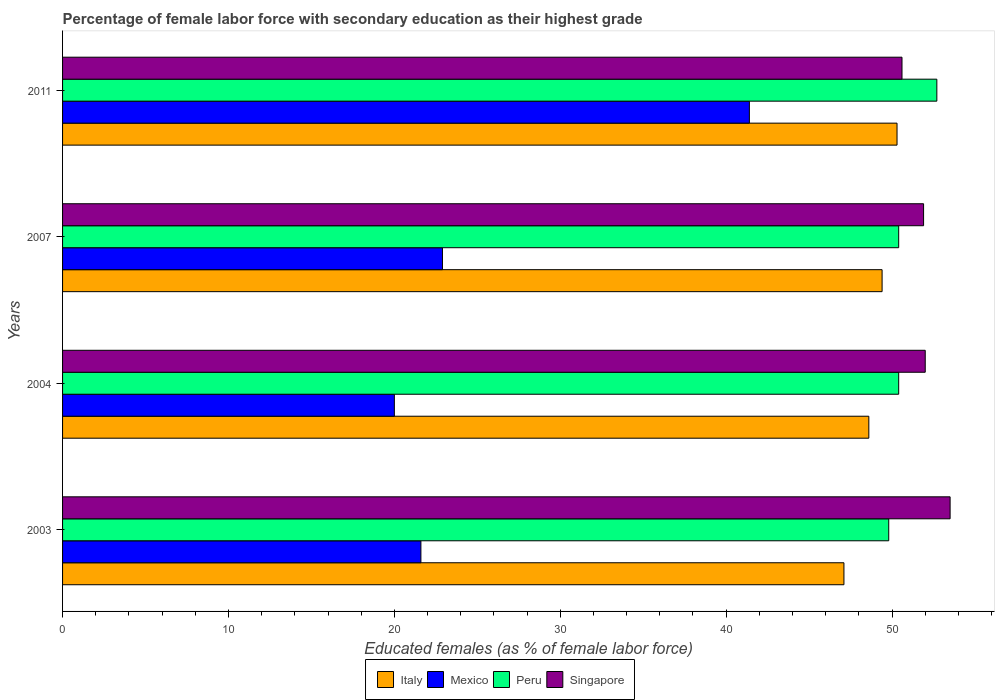Are the number of bars per tick equal to the number of legend labels?
Ensure brevity in your answer.  Yes. How many bars are there on the 4th tick from the bottom?
Ensure brevity in your answer.  4. In how many cases, is the number of bars for a given year not equal to the number of legend labels?
Offer a terse response. 0. What is the percentage of female labor force with secondary education in Singapore in 2003?
Provide a succinct answer. 53.5. Across all years, what is the maximum percentage of female labor force with secondary education in Mexico?
Ensure brevity in your answer.  41.4. Across all years, what is the minimum percentage of female labor force with secondary education in Peru?
Provide a succinct answer. 49.8. In which year was the percentage of female labor force with secondary education in Italy minimum?
Provide a succinct answer. 2003. What is the total percentage of female labor force with secondary education in Mexico in the graph?
Make the answer very short. 105.9. What is the difference between the percentage of female labor force with secondary education in Singapore in 2004 and that in 2007?
Make the answer very short. 0.1. What is the difference between the percentage of female labor force with secondary education in Peru in 2004 and the percentage of female labor force with secondary education in Mexico in 2007?
Offer a very short reply. 27.5. What is the average percentage of female labor force with secondary education in Italy per year?
Offer a very short reply. 48.85. In the year 2003, what is the difference between the percentage of female labor force with secondary education in Mexico and percentage of female labor force with secondary education in Singapore?
Your response must be concise. -31.9. In how many years, is the percentage of female labor force with secondary education in Singapore greater than 46 %?
Your answer should be very brief. 4. What is the ratio of the percentage of female labor force with secondary education in Singapore in 2003 to that in 2007?
Offer a terse response. 1.03. Is the percentage of female labor force with secondary education in Italy in 2003 less than that in 2004?
Offer a very short reply. Yes. What is the difference between the highest and the lowest percentage of female labor force with secondary education in Singapore?
Ensure brevity in your answer.  2.9. Is the sum of the percentage of female labor force with secondary education in Mexico in 2003 and 2011 greater than the maximum percentage of female labor force with secondary education in Singapore across all years?
Offer a very short reply. Yes. Is it the case that in every year, the sum of the percentage of female labor force with secondary education in Italy and percentage of female labor force with secondary education in Peru is greater than the sum of percentage of female labor force with secondary education in Mexico and percentage of female labor force with secondary education in Singapore?
Provide a short and direct response. No. What does the 1st bar from the top in 2004 represents?
Provide a short and direct response. Singapore. What does the 1st bar from the bottom in 2004 represents?
Your answer should be compact. Italy. Is it the case that in every year, the sum of the percentage of female labor force with secondary education in Singapore and percentage of female labor force with secondary education in Mexico is greater than the percentage of female labor force with secondary education in Peru?
Offer a very short reply. Yes. How many bars are there?
Keep it short and to the point. 16. What is the difference between two consecutive major ticks on the X-axis?
Give a very brief answer. 10. Are the values on the major ticks of X-axis written in scientific E-notation?
Provide a short and direct response. No. Does the graph contain any zero values?
Your response must be concise. No. Where does the legend appear in the graph?
Offer a terse response. Bottom center. How many legend labels are there?
Your answer should be compact. 4. What is the title of the graph?
Your answer should be compact. Percentage of female labor force with secondary education as their highest grade. Does "Bangladesh" appear as one of the legend labels in the graph?
Offer a very short reply. No. What is the label or title of the X-axis?
Make the answer very short. Educated females (as % of female labor force). What is the label or title of the Y-axis?
Keep it short and to the point. Years. What is the Educated females (as % of female labor force) in Italy in 2003?
Offer a terse response. 47.1. What is the Educated females (as % of female labor force) of Mexico in 2003?
Make the answer very short. 21.6. What is the Educated females (as % of female labor force) of Peru in 2003?
Make the answer very short. 49.8. What is the Educated females (as % of female labor force) of Singapore in 2003?
Your answer should be compact. 53.5. What is the Educated females (as % of female labor force) of Italy in 2004?
Provide a succinct answer. 48.6. What is the Educated females (as % of female labor force) of Mexico in 2004?
Offer a very short reply. 20. What is the Educated females (as % of female labor force) in Peru in 2004?
Your response must be concise. 50.4. What is the Educated females (as % of female labor force) of Singapore in 2004?
Offer a very short reply. 52. What is the Educated females (as % of female labor force) of Italy in 2007?
Ensure brevity in your answer.  49.4. What is the Educated females (as % of female labor force) in Mexico in 2007?
Provide a short and direct response. 22.9. What is the Educated females (as % of female labor force) in Peru in 2007?
Make the answer very short. 50.4. What is the Educated females (as % of female labor force) in Singapore in 2007?
Give a very brief answer. 51.9. What is the Educated females (as % of female labor force) of Italy in 2011?
Ensure brevity in your answer.  50.3. What is the Educated females (as % of female labor force) of Mexico in 2011?
Keep it short and to the point. 41.4. What is the Educated females (as % of female labor force) of Peru in 2011?
Your response must be concise. 52.7. What is the Educated females (as % of female labor force) of Singapore in 2011?
Ensure brevity in your answer.  50.6. Across all years, what is the maximum Educated females (as % of female labor force) in Italy?
Offer a very short reply. 50.3. Across all years, what is the maximum Educated females (as % of female labor force) of Mexico?
Ensure brevity in your answer.  41.4. Across all years, what is the maximum Educated females (as % of female labor force) of Peru?
Give a very brief answer. 52.7. Across all years, what is the maximum Educated females (as % of female labor force) in Singapore?
Provide a succinct answer. 53.5. Across all years, what is the minimum Educated females (as % of female labor force) of Italy?
Make the answer very short. 47.1. Across all years, what is the minimum Educated females (as % of female labor force) of Peru?
Keep it short and to the point. 49.8. Across all years, what is the minimum Educated females (as % of female labor force) in Singapore?
Give a very brief answer. 50.6. What is the total Educated females (as % of female labor force) of Italy in the graph?
Provide a succinct answer. 195.4. What is the total Educated females (as % of female labor force) of Mexico in the graph?
Provide a short and direct response. 105.9. What is the total Educated females (as % of female labor force) of Peru in the graph?
Make the answer very short. 203.3. What is the total Educated females (as % of female labor force) of Singapore in the graph?
Make the answer very short. 208. What is the difference between the Educated females (as % of female labor force) in Singapore in 2003 and that in 2004?
Keep it short and to the point. 1.5. What is the difference between the Educated females (as % of female labor force) of Italy in 2003 and that in 2007?
Your answer should be compact. -2.3. What is the difference between the Educated females (as % of female labor force) of Singapore in 2003 and that in 2007?
Offer a very short reply. 1.6. What is the difference between the Educated females (as % of female labor force) of Mexico in 2003 and that in 2011?
Provide a succinct answer. -19.8. What is the difference between the Educated females (as % of female labor force) of Peru in 2003 and that in 2011?
Keep it short and to the point. -2.9. What is the difference between the Educated females (as % of female labor force) in Singapore in 2003 and that in 2011?
Your answer should be very brief. 2.9. What is the difference between the Educated females (as % of female labor force) in Peru in 2004 and that in 2007?
Your answer should be compact. 0. What is the difference between the Educated females (as % of female labor force) in Mexico in 2004 and that in 2011?
Keep it short and to the point. -21.4. What is the difference between the Educated females (as % of female labor force) of Mexico in 2007 and that in 2011?
Your response must be concise. -18.5. What is the difference between the Educated females (as % of female labor force) in Peru in 2007 and that in 2011?
Provide a short and direct response. -2.3. What is the difference between the Educated females (as % of female labor force) in Italy in 2003 and the Educated females (as % of female labor force) in Mexico in 2004?
Offer a very short reply. 27.1. What is the difference between the Educated females (as % of female labor force) of Italy in 2003 and the Educated females (as % of female labor force) of Peru in 2004?
Your response must be concise. -3.3. What is the difference between the Educated females (as % of female labor force) of Mexico in 2003 and the Educated females (as % of female labor force) of Peru in 2004?
Provide a succinct answer. -28.8. What is the difference between the Educated females (as % of female labor force) of Mexico in 2003 and the Educated females (as % of female labor force) of Singapore in 2004?
Provide a short and direct response. -30.4. What is the difference between the Educated females (as % of female labor force) in Peru in 2003 and the Educated females (as % of female labor force) in Singapore in 2004?
Make the answer very short. -2.2. What is the difference between the Educated females (as % of female labor force) of Italy in 2003 and the Educated females (as % of female labor force) of Mexico in 2007?
Make the answer very short. 24.2. What is the difference between the Educated females (as % of female labor force) of Italy in 2003 and the Educated females (as % of female labor force) of Peru in 2007?
Provide a short and direct response. -3.3. What is the difference between the Educated females (as % of female labor force) of Mexico in 2003 and the Educated females (as % of female labor force) of Peru in 2007?
Your answer should be very brief. -28.8. What is the difference between the Educated females (as % of female labor force) in Mexico in 2003 and the Educated females (as % of female labor force) in Singapore in 2007?
Your answer should be very brief. -30.3. What is the difference between the Educated females (as % of female labor force) in Peru in 2003 and the Educated females (as % of female labor force) in Singapore in 2007?
Your answer should be compact. -2.1. What is the difference between the Educated females (as % of female labor force) in Italy in 2003 and the Educated females (as % of female labor force) in Mexico in 2011?
Keep it short and to the point. 5.7. What is the difference between the Educated females (as % of female labor force) in Mexico in 2003 and the Educated females (as % of female labor force) in Peru in 2011?
Your answer should be very brief. -31.1. What is the difference between the Educated females (as % of female labor force) of Mexico in 2003 and the Educated females (as % of female labor force) of Singapore in 2011?
Provide a short and direct response. -29. What is the difference between the Educated females (as % of female labor force) in Peru in 2003 and the Educated females (as % of female labor force) in Singapore in 2011?
Your response must be concise. -0.8. What is the difference between the Educated females (as % of female labor force) in Italy in 2004 and the Educated females (as % of female labor force) in Mexico in 2007?
Your response must be concise. 25.7. What is the difference between the Educated females (as % of female labor force) of Italy in 2004 and the Educated females (as % of female labor force) of Peru in 2007?
Provide a succinct answer. -1.8. What is the difference between the Educated females (as % of female labor force) of Mexico in 2004 and the Educated females (as % of female labor force) of Peru in 2007?
Offer a terse response. -30.4. What is the difference between the Educated females (as % of female labor force) in Mexico in 2004 and the Educated females (as % of female labor force) in Singapore in 2007?
Provide a succinct answer. -31.9. What is the difference between the Educated females (as % of female labor force) in Peru in 2004 and the Educated females (as % of female labor force) in Singapore in 2007?
Offer a terse response. -1.5. What is the difference between the Educated females (as % of female labor force) of Italy in 2004 and the Educated females (as % of female labor force) of Mexico in 2011?
Make the answer very short. 7.2. What is the difference between the Educated females (as % of female labor force) of Italy in 2004 and the Educated females (as % of female labor force) of Peru in 2011?
Provide a short and direct response. -4.1. What is the difference between the Educated females (as % of female labor force) of Mexico in 2004 and the Educated females (as % of female labor force) of Peru in 2011?
Keep it short and to the point. -32.7. What is the difference between the Educated females (as % of female labor force) of Mexico in 2004 and the Educated females (as % of female labor force) of Singapore in 2011?
Make the answer very short. -30.6. What is the difference between the Educated females (as % of female labor force) in Italy in 2007 and the Educated females (as % of female labor force) in Singapore in 2011?
Ensure brevity in your answer.  -1.2. What is the difference between the Educated females (as % of female labor force) in Mexico in 2007 and the Educated females (as % of female labor force) in Peru in 2011?
Ensure brevity in your answer.  -29.8. What is the difference between the Educated females (as % of female labor force) in Mexico in 2007 and the Educated females (as % of female labor force) in Singapore in 2011?
Keep it short and to the point. -27.7. What is the difference between the Educated females (as % of female labor force) in Peru in 2007 and the Educated females (as % of female labor force) in Singapore in 2011?
Offer a terse response. -0.2. What is the average Educated females (as % of female labor force) of Italy per year?
Your response must be concise. 48.85. What is the average Educated females (as % of female labor force) of Mexico per year?
Offer a very short reply. 26.48. What is the average Educated females (as % of female labor force) in Peru per year?
Offer a terse response. 50.83. In the year 2003, what is the difference between the Educated females (as % of female labor force) in Italy and Educated females (as % of female labor force) in Peru?
Keep it short and to the point. -2.7. In the year 2003, what is the difference between the Educated females (as % of female labor force) of Mexico and Educated females (as % of female labor force) of Peru?
Your response must be concise. -28.2. In the year 2003, what is the difference between the Educated females (as % of female labor force) in Mexico and Educated females (as % of female labor force) in Singapore?
Ensure brevity in your answer.  -31.9. In the year 2004, what is the difference between the Educated females (as % of female labor force) in Italy and Educated females (as % of female labor force) in Mexico?
Offer a very short reply. 28.6. In the year 2004, what is the difference between the Educated females (as % of female labor force) in Italy and Educated females (as % of female labor force) in Peru?
Provide a succinct answer. -1.8. In the year 2004, what is the difference between the Educated females (as % of female labor force) in Mexico and Educated females (as % of female labor force) in Peru?
Give a very brief answer. -30.4. In the year 2004, what is the difference between the Educated females (as % of female labor force) in Mexico and Educated females (as % of female labor force) in Singapore?
Your response must be concise. -32. In the year 2007, what is the difference between the Educated females (as % of female labor force) of Italy and Educated females (as % of female labor force) of Mexico?
Offer a terse response. 26.5. In the year 2007, what is the difference between the Educated females (as % of female labor force) in Italy and Educated females (as % of female labor force) in Peru?
Make the answer very short. -1. In the year 2007, what is the difference between the Educated females (as % of female labor force) in Italy and Educated females (as % of female labor force) in Singapore?
Your answer should be compact. -2.5. In the year 2007, what is the difference between the Educated females (as % of female labor force) in Mexico and Educated females (as % of female labor force) in Peru?
Keep it short and to the point. -27.5. In the year 2007, what is the difference between the Educated females (as % of female labor force) in Peru and Educated females (as % of female labor force) in Singapore?
Ensure brevity in your answer.  -1.5. In the year 2011, what is the difference between the Educated females (as % of female labor force) in Italy and Educated females (as % of female labor force) in Mexico?
Offer a terse response. 8.9. In the year 2011, what is the difference between the Educated females (as % of female labor force) in Italy and Educated females (as % of female labor force) in Peru?
Provide a succinct answer. -2.4. In the year 2011, what is the difference between the Educated females (as % of female labor force) in Italy and Educated females (as % of female labor force) in Singapore?
Provide a succinct answer. -0.3. In the year 2011, what is the difference between the Educated females (as % of female labor force) in Mexico and Educated females (as % of female labor force) in Singapore?
Ensure brevity in your answer.  -9.2. What is the ratio of the Educated females (as % of female labor force) of Italy in 2003 to that in 2004?
Make the answer very short. 0.97. What is the ratio of the Educated females (as % of female labor force) in Singapore in 2003 to that in 2004?
Offer a very short reply. 1.03. What is the ratio of the Educated females (as % of female labor force) of Italy in 2003 to that in 2007?
Your answer should be very brief. 0.95. What is the ratio of the Educated females (as % of female labor force) of Mexico in 2003 to that in 2007?
Give a very brief answer. 0.94. What is the ratio of the Educated females (as % of female labor force) in Peru in 2003 to that in 2007?
Provide a succinct answer. 0.99. What is the ratio of the Educated females (as % of female labor force) in Singapore in 2003 to that in 2007?
Ensure brevity in your answer.  1.03. What is the ratio of the Educated females (as % of female labor force) in Italy in 2003 to that in 2011?
Offer a very short reply. 0.94. What is the ratio of the Educated females (as % of female labor force) of Mexico in 2003 to that in 2011?
Offer a terse response. 0.52. What is the ratio of the Educated females (as % of female labor force) of Peru in 2003 to that in 2011?
Make the answer very short. 0.94. What is the ratio of the Educated females (as % of female labor force) in Singapore in 2003 to that in 2011?
Provide a short and direct response. 1.06. What is the ratio of the Educated females (as % of female labor force) of Italy in 2004 to that in 2007?
Your response must be concise. 0.98. What is the ratio of the Educated females (as % of female labor force) of Mexico in 2004 to that in 2007?
Ensure brevity in your answer.  0.87. What is the ratio of the Educated females (as % of female labor force) of Singapore in 2004 to that in 2007?
Give a very brief answer. 1. What is the ratio of the Educated females (as % of female labor force) in Italy in 2004 to that in 2011?
Offer a terse response. 0.97. What is the ratio of the Educated females (as % of female labor force) of Mexico in 2004 to that in 2011?
Your response must be concise. 0.48. What is the ratio of the Educated females (as % of female labor force) of Peru in 2004 to that in 2011?
Offer a very short reply. 0.96. What is the ratio of the Educated females (as % of female labor force) of Singapore in 2004 to that in 2011?
Ensure brevity in your answer.  1.03. What is the ratio of the Educated females (as % of female labor force) in Italy in 2007 to that in 2011?
Provide a short and direct response. 0.98. What is the ratio of the Educated females (as % of female labor force) of Mexico in 2007 to that in 2011?
Give a very brief answer. 0.55. What is the ratio of the Educated females (as % of female labor force) of Peru in 2007 to that in 2011?
Keep it short and to the point. 0.96. What is the ratio of the Educated females (as % of female labor force) in Singapore in 2007 to that in 2011?
Make the answer very short. 1.03. What is the difference between the highest and the second highest Educated females (as % of female labor force) in Peru?
Your answer should be very brief. 2.3. What is the difference between the highest and the second highest Educated females (as % of female labor force) in Singapore?
Provide a succinct answer. 1.5. What is the difference between the highest and the lowest Educated females (as % of female labor force) in Italy?
Offer a very short reply. 3.2. What is the difference between the highest and the lowest Educated females (as % of female labor force) in Mexico?
Make the answer very short. 21.4. What is the difference between the highest and the lowest Educated females (as % of female labor force) of Singapore?
Your answer should be very brief. 2.9. 